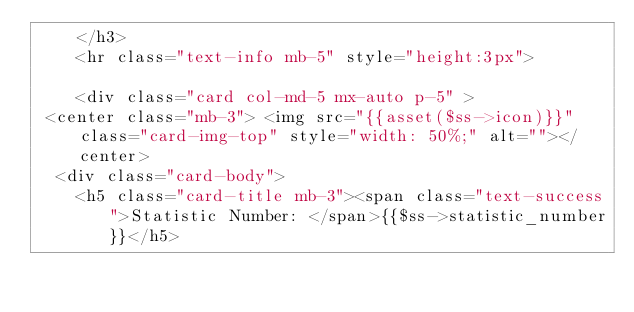<code> <loc_0><loc_0><loc_500><loc_500><_PHP_>    </h3>
    <hr class="text-info mb-5" style="height:3px">
      
    <div class="card col-md-5 mx-auto p-5" >
 <center class="mb-3"> <img src="{{asset($ss->icon)}}" class="card-img-top" style="width: 50%;" alt=""></center>
  <div class="card-body">
    <h5 class="card-title mb-3"><span class="text-success">Statistic Number: </span>{{$ss->statistic_number}}</h5></code> 